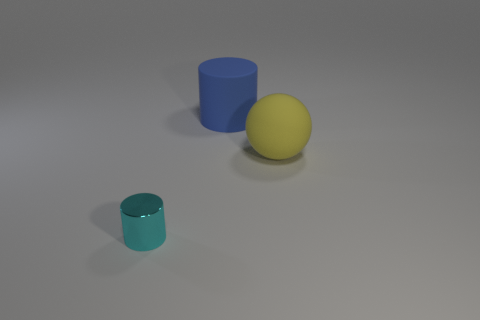Add 2 cylinders. How many objects exist? 5 Subtract all spheres. How many objects are left? 2 Add 3 blue objects. How many blue objects exist? 4 Subtract 0 cyan cubes. How many objects are left? 3 Subtract all green shiny cubes. Subtract all blue rubber things. How many objects are left? 2 Add 1 big blue cylinders. How many big blue cylinders are left? 2 